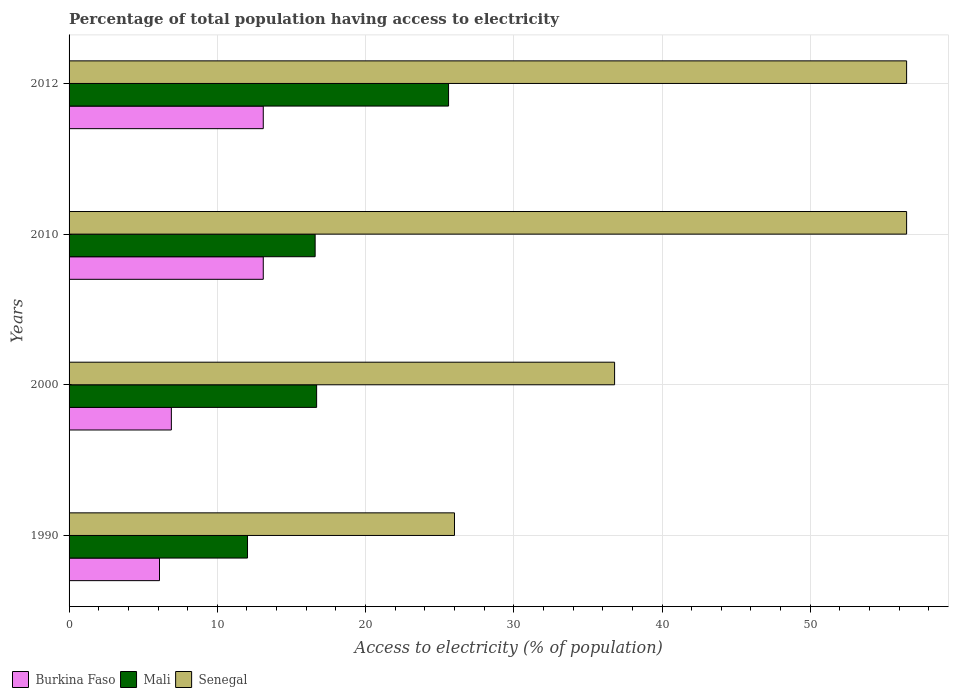How many groups of bars are there?
Give a very brief answer. 4. Are the number of bars on each tick of the Y-axis equal?
Give a very brief answer. Yes. How many bars are there on the 1st tick from the top?
Ensure brevity in your answer.  3. What is the percentage of population that have access to electricity in Burkina Faso in 2012?
Keep it short and to the point. 13.1. Across all years, what is the maximum percentage of population that have access to electricity in Senegal?
Offer a terse response. 56.5. Across all years, what is the minimum percentage of population that have access to electricity in Mali?
Keep it short and to the point. 12.04. What is the total percentage of population that have access to electricity in Burkina Faso in the graph?
Provide a short and direct response. 39.2. What is the difference between the percentage of population that have access to electricity in Mali in 1990 and that in 2010?
Ensure brevity in your answer.  -4.56. What is the difference between the percentage of population that have access to electricity in Mali in 2010 and the percentage of population that have access to electricity in Burkina Faso in 2000?
Make the answer very short. 9.7. What is the average percentage of population that have access to electricity in Burkina Faso per year?
Your answer should be compact. 9.8. In the year 2012, what is the difference between the percentage of population that have access to electricity in Mali and percentage of population that have access to electricity in Burkina Faso?
Your answer should be compact. 12.5. In how many years, is the percentage of population that have access to electricity in Burkina Faso greater than 2 %?
Provide a succinct answer. 4. Is the percentage of population that have access to electricity in Burkina Faso in 1990 less than that in 2012?
Give a very brief answer. Yes. What is the difference between the highest and the second highest percentage of population that have access to electricity in Mali?
Offer a very short reply. 8.9. What is the difference between the highest and the lowest percentage of population that have access to electricity in Mali?
Offer a very short reply. 13.56. In how many years, is the percentage of population that have access to electricity in Senegal greater than the average percentage of population that have access to electricity in Senegal taken over all years?
Provide a succinct answer. 2. Is the sum of the percentage of population that have access to electricity in Mali in 1990 and 2000 greater than the maximum percentage of population that have access to electricity in Senegal across all years?
Ensure brevity in your answer.  No. What does the 2nd bar from the top in 2012 represents?
Give a very brief answer. Mali. What does the 3rd bar from the bottom in 2012 represents?
Offer a terse response. Senegal. Is it the case that in every year, the sum of the percentage of population that have access to electricity in Senegal and percentage of population that have access to electricity in Burkina Faso is greater than the percentage of population that have access to electricity in Mali?
Your answer should be compact. Yes. How many bars are there?
Your response must be concise. 12. Are all the bars in the graph horizontal?
Give a very brief answer. Yes. How many years are there in the graph?
Offer a terse response. 4. What is the difference between two consecutive major ticks on the X-axis?
Ensure brevity in your answer.  10. Are the values on the major ticks of X-axis written in scientific E-notation?
Provide a succinct answer. No. Does the graph contain any zero values?
Ensure brevity in your answer.  No. How many legend labels are there?
Offer a terse response. 3. What is the title of the graph?
Offer a very short reply. Percentage of total population having access to electricity. What is the label or title of the X-axis?
Provide a succinct answer. Access to electricity (% of population). What is the Access to electricity (% of population) of Mali in 1990?
Ensure brevity in your answer.  12.04. What is the Access to electricity (% of population) of Senegal in 1990?
Ensure brevity in your answer.  26. What is the Access to electricity (% of population) of Mali in 2000?
Offer a terse response. 16.7. What is the Access to electricity (% of population) of Senegal in 2000?
Your answer should be compact. 36.8. What is the Access to electricity (% of population) in Senegal in 2010?
Ensure brevity in your answer.  56.5. What is the Access to electricity (% of population) in Burkina Faso in 2012?
Your response must be concise. 13.1. What is the Access to electricity (% of population) in Mali in 2012?
Offer a terse response. 25.6. What is the Access to electricity (% of population) in Senegal in 2012?
Your answer should be very brief. 56.5. Across all years, what is the maximum Access to electricity (% of population) in Mali?
Make the answer very short. 25.6. Across all years, what is the maximum Access to electricity (% of population) of Senegal?
Offer a very short reply. 56.5. Across all years, what is the minimum Access to electricity (% of population) of Mali?
Your response must be concise. 12.04. Across all years, what is the minimum Access to electricity (% of population) of Senegal?
Offer a terse response. 26. What is the total Access to electricity (% of population) of Burkina Faso in the graph?
Your response must be concise. 39.2. What is the total Access to electricity (% of population) of Mali in the graph?
Offer a very short reply. 70.94. What is the total Access to electricity (% of population) in Senegal in the graph?
Make the answer very short. 175.8. What is the difference between the Access to electricity (% of population) of Burkina Faso in 1990 and that in 2000?
Provide a succinct answer. -0.8. What is the difference between the Access to electricity (% of population) of Mali in 1990 and that in 2000?
Provide a succinct answer. -4.66. What is the difference between the Access to electricity (% of population) in Senegal in 1990 and that in 2000?
Offer a terse response. -10.8. What is the difference between the Access to electricity (% of population) in Burkina Faso in 1990 and that in 2010?
Offer a very short reply. -7. What is the difference between the Access to electricity (% of population) in Mali in 1990 and that in 2010?
Make the answer very short. -4.56. What is the difference between the Access to electricity (% of population) in Senegal in 1990 and that in 2010?
Your answer should be compact. -30.5. What is the difference between the Access to electricity (% of population) of Mali in 1990 and that in 2012?
Give a very brief answer. -13.56. What is the difference between the Access to electricity (% of population) in Senegal in 1990 and that in 2012?
Ensure brevity in your answer.  -30.5. What is the difference between the Access to electricity (% of population) of Mali in 2000 and that in 2010?
Make the answer very short. 0.1. What is the difference between the Access to electricity (% of population) in Senegal in 2000 and that in 2010?
Provide a succinct answer. -19.7. What is the difference between the Access to electricity (% of population) of Burkina Faso in 2000 and that in 2012?
Make the answer very short. -6.2. What is the difference between the Access to electricity (% of population) of Senegal in 2000 and that in 2012?
Your response must be concise. -19.7. What is the difference between the Access to electricity (% of population) of Burkina Faso in 2010 and that in 2012?
Offer a very short reply. 0. What is the difference between the Access to electricity (% of population) of Burkina Faso in 1990 and the Access to electricity (% of population) of Senegal in 2000?
Your answer should be very brief. -30.7. What is the difference between the Access to electricity (% of population) in Mali in 1990 and the Access to electricity (% of population) in Senegal in 2000?
Offer a very short reply. -24.76. What is the difference between the Access to electricity (% of population) in Burkina Faso in 1990 and the Access to electricity (% of population) in Mali in 2010?
Keep it short and to the point. -10.5. What is the difference between the Access to electricity (% of population) in Burkina Faso in 1990 and the Access to electricity (% of population) in Senegal in 2010?
Provide a succinct answer. -50.4. What is the difference between the Access to electricity (% of population) of Mali in 1990 and the Access to electricity (% of population) of Senegal in 2010?
Offer a very short reply. -44.46. What is the difference between the Access to electricity (% of population) in Burkina Faso in 1990 and the Access to electricity (% of population) in Mali in 2012?
Provide a succinct answer. -19.5. What is the difference between the Access to electricity (% of population) in Burkina Faso in 1990 and the Access to electricity (% of population) in Senegal in 2012?
Keep it short and to the point. -50.4. What is the difference between the Access to electricity (% of population) in Mali in 1990 and the Access to electricity (% of population) in Senegal in 2012?
Ensure brevity in your answer.  -44.46. What is the difference between the Access to electricity (% of population) in Burkina Faso in 2000 and the Access to electricity (% of population) in Senegal in 2010?
Provide a short and direct response. -49.6. What is the difference between the Access to electricity (% of population) in Mali in 2000 and the Access to electricity (% of population) in Senegal in 2010?
Make the answer very short. -39.8. What is the difference between the Access to electricity (% of population) of Burkina Faso in 2000 and the Access to electricity (% of population) of Mali in 2012?
Ensure brevity in your answer.  -18.7. What is the difference between the Access to electricity (% of population) in Burkina Faso in 2000 and the Access to electricity (% of population) in Senegal in 2012?
Your answer should be very brief. -49.6. What is the difference between the Access to electricity (% of population) in Mali in 2000 and the Access to electricity (% of population) in Senegal in 2012?
Give a very brief answer. -39.8. What is the difference between the Access to electricity (% of population) in Burkina Faso in 2010 and the Access to electricity (% of population) in Senegal in 2012?
Your answer should be very brief. -43.4. What is the difference between the Access to electricity (% of population) in Mali in 2010 and the Access to electricity (% of population) in Senegal in 2012?
Offer a very short reply. -39.9. What is the average Access to electricity (% of population) of Burkina Faso per year?
Provide a succinct answer. 9.8. What is the average Access to electricity (% of population) of Mali per year?
Give a very brief answer. 17.73. What is the average Access to electricity (% of population) in Senegal per year?
Offer a very short reply. 43.95. In the year 1990, what is the difference between the Access to electricity (% of population) of Burkina Faso and Access to electricity (% of population) of Mali?
Offer a terse response. -5.94. In the year 1990, what is the difference between the Access to electricity (% of population) of Burkina Faso and Access to electricity (% of population) of Senegal?
Make the answer very short. -19.9. In the year 1990, what is the difference between the Access to electricity (% of population) in Mali and Access to electricity (% of population) in Senegal?
Make the answer very short. -13.96. In the year 2000, what is the difference between the Access to electricity (% of population) in Burkina Faso and Access to electricity (% of population) in Senegal?
Offer a terse response. -29.9. In the year 2000, what is the difference between the Access to electricity (% of population) in Mali and Access to electricity (% of population) in Senegal?
Give a very brief answer. -20.1. In the year 2010, what is the difference between the Access to electricity (% of population) of Burkina Faso and Access to electricity (% of population) of Mali?
Offer a very short reply. -3.5. In the year 2010, what is the difference between the Access to electricity (% of population) in Burkina Faso and Access to electricity (% of population) in Senegal?
Give a very brief answer. -43.4. In the year 2010, what is the difference between the Access to electricity (% of population) of Mali and Access to electricity (% of population) of Senegal?
Provide a short and direct response. -39.9. In the year 2012, what is the difference between the Access to electricity (% of population) of Burkina Faso and Access to electricity (% of population) of Senegal?
Offer a terse response. -43.4. In the year 2012, what is the difference between the Access to electricity (% of population) of Mali and Access to electricity (% of population) of Senegal?
Keep it short and to the point. -30.9. What is the ratio of the Access to electricity (% of population) of Burkina Faso in 1990 to that in 2000?
Ensure brevity in your answer.  0.88. What is the ratio of the Access to electricity (% of population) of Mali in 1990 to that in 2000?
Ensure brevity in your answer.  0.72. What is the ratio of the Access to electricity (% of population) of Senegal in 1990 to that in 2000?
Your response must be concise. 0.71. What is the ratio of the Access to electricity (% of population) in Burkina Faso in 1990 to that in 2010?
Your answer should be compact. 0.47. What is the ratio of the Access to electricity (% of population) in Mali in 1990 to that in 2010?
Your answer should be compact. 0.73. What is the ratio of the Access to electricity (% of population) in Senegal in 1990 to that in 2010?
Keep it short and to the point. 0.46. What is the ratio of the Access to electricity (% of population) of Burkina Faso in 1990 to that in 2012?
Your answer should be very brief. 0.47. What is the ratio of the Access to electricity (% of population) in Mali in 1990 to that in 2012?
Provide a short and direct response. 0.47. What is the ratio of the Access to electricity (% of population) of Senegal in 1990 to that in 2012?
Make the answer very short. 0.46. What is the ratio of the Access to electricity (% of population) of Burkina Faso in 2000 to that in 2010?
Your answer should be compact. 0.53. What is the ratio of the Access to electricity (% of population) of Senegal in 2000 to that in 2010?
Offer a very short reply. 0.65. What is the ratio of the Access to electricity (% of population) of Burkina Faso in 2000 to that in 2012?
Keep it short and to the point. 0.53. What is the ratio of the Access to electricity (% of population) of Mali in 2000 to that in 2012?
Your response must be concise. 0.65. What is the ratio of the Access to electricity (% of population) in Senegal in 2000 to that in 2012?
Provide a succinct answer. 0.65. What is the ratio of the Access to electricity (% of population) in Burkina Faso in 2010 to that in 2012?
Keep it short and to the point. 1. What is the ratio of the Access to electricity (% of population) in Mali in 2010 to that in 2012?
Your answer should be very brief. 0.65. What is the ratio of the Access to electricity (% of population) of Senegal in 2010 to that in 2012?
Make the answer very short. 1. What is the difference between the highest and the second highest Access to electricity (% of population) of Mali?
Your answer should be very brief. 8.9. What is the difference between the highest and the lowest Access to electricity (% of population) in Burkina Faso?
Offer a very short reply. 7. What is the difference between the highest and the lowest Access to electricity (% of population) of Mali?
Your response must be concise. 13.56. What is the difference between the highest and the lowest Access to electricity (% of population) in Senegal?
Make the answer very short. 30.5. 